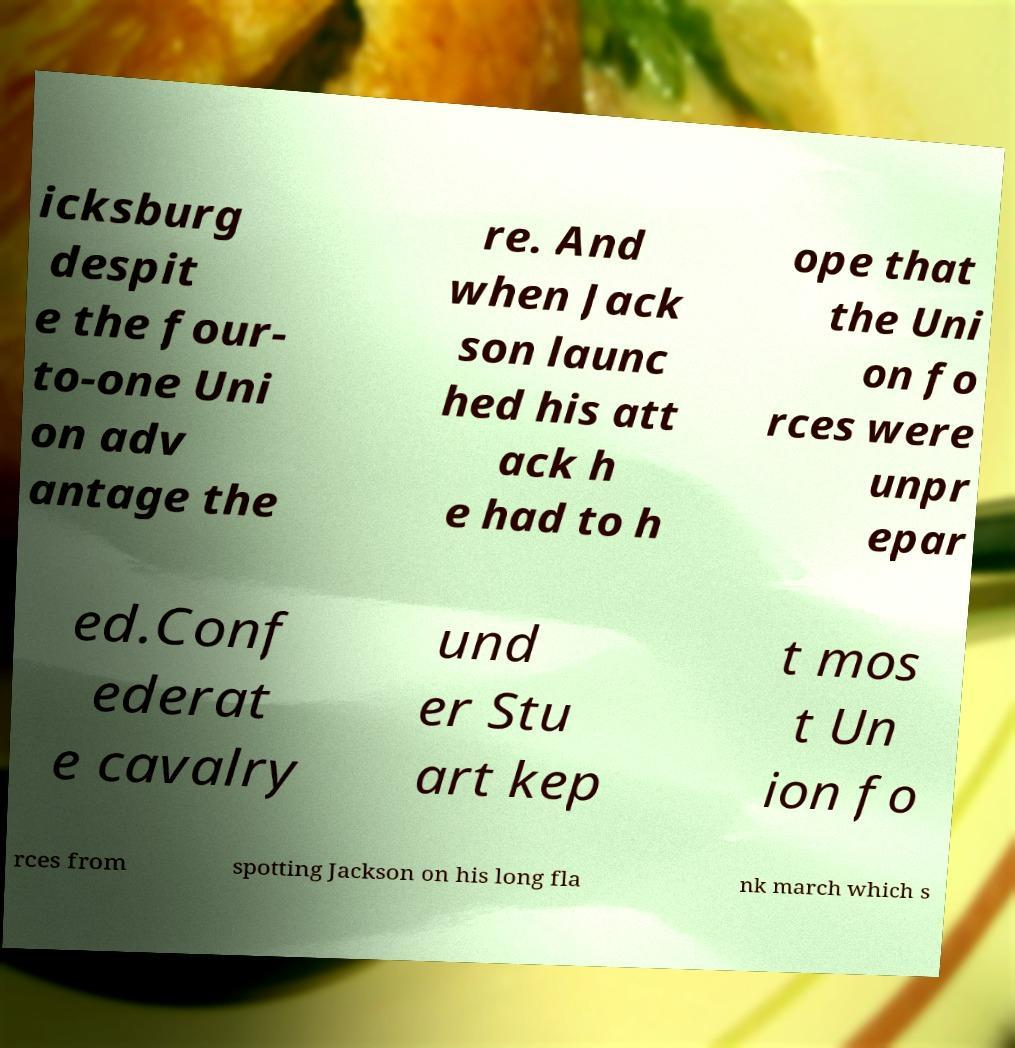There's text embedded in this image that I need extracted. Can you transcribe it verbatim? icksburg despit e the four- to-one Uni on adv antage the re. And when Jack son launc hed his att ack h e had to h ope that the Uni on fo rces were unpr epar ed.Conf ederat e cavalry und er Stu art kep t mos t Un ion fo rces from spotting Jackson on his long fla nk march which s 